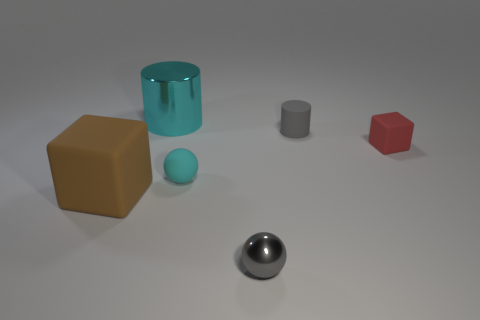How many cylinders are large brown rubber objects or tiny metallic things?
Give a very brief answer. 0. There is another shiny ball that is the same size as the cyan sphere; what is its color?
Offer a terse response. Gray. The object behind the rubber cylinder behind the tiny metal sphere is what shape?
Your answer should be compact. Cylinder. There is a sphere in front of the brown rubber cube; is its size the same as the brown rubber object?
Offer a terse response. No. What number of other things are made of the same material as the large cyan object?
Make the answer very short. 1. What number of gray objects are either tiny blocks or big rubber cubes?
Your answer should be compact. 0. There is a thing that is the same color as the big cylinder; what size is it?
Your answer should be very brief. Small. How many rubber objects are in front of the tiny cylinder?
Ensure brevity in your answer.  3. What is the size of the gray rubber thing on the right side of the cylinder that is to the left of the tiny cyan sphere that is in front of the big cylinder?
Give a very brief answer. Small. Is there a cyan cylinder on the right side of the gray thing that is behind the red rubber cube in front of the tiny matte cylinder?
Your answer should be compact. No. 